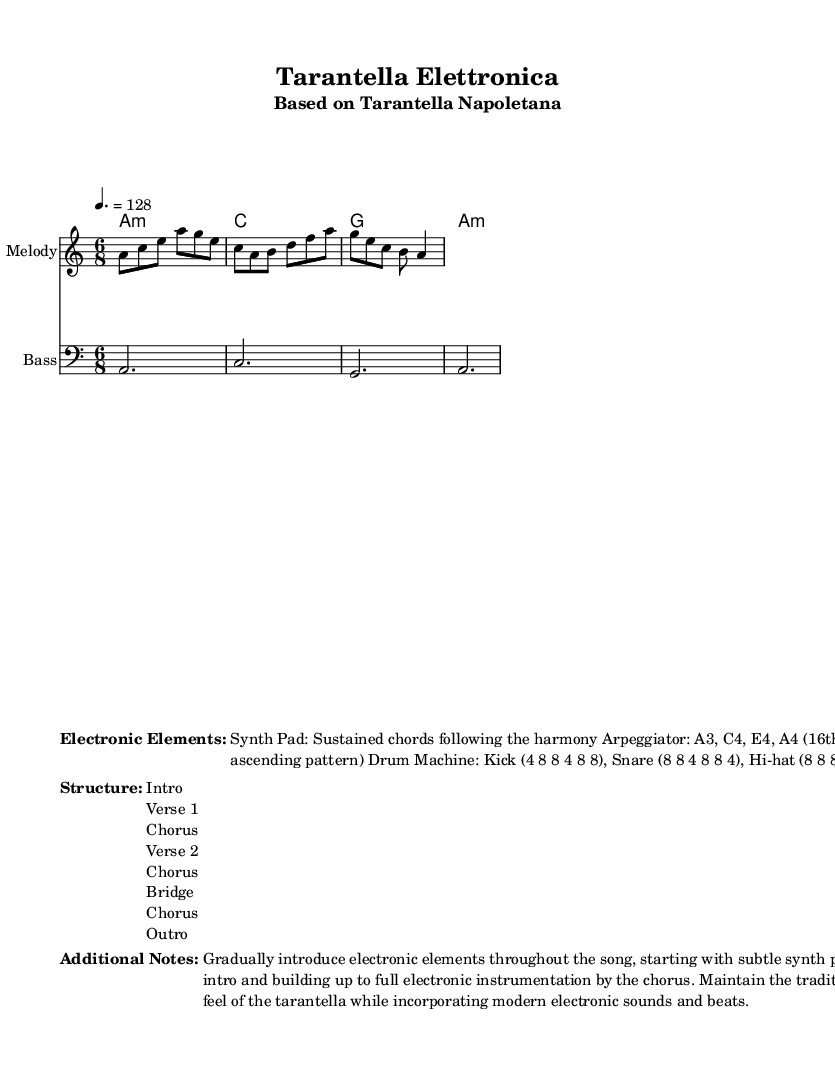What is the key signature of this music? The key signature is A minor, which has no sharps or flats.
Answer: A minor What is the time signature of this music? The time signature shown is 6/8, which indicates there are six eighth notes in each measure.
Answer: 6/8 What is the tempo marking for this piece? The tempo marking states a quarter note equals 128 beats per minute, indicating a brisk pace.
Answer: 128 How many verses are in the structure of this piece? The structure indicates two verses before the bridge and choruses which reveals that there are two verses.
Answer: 2 What type of electronic element is introduced in the intro? The intro introduces subtle synth pads, which provide a sustained harmonic background.
Answer: Synth Pad How does the electronic instrumentation build up in the chorus? In the chorus, the electronic instrumentation builds up to full instrumentation, indicating a climax with all elements present.
Answer: Full electronic instrumentation What rhythm pattern is used for the kick in the drum machine? The rhythm pattern for the kick is outlined as 4 8 8 4 8 8, indicating specific beats for the kick drum in the song.
Answer: 4 8 8 4 8 8 